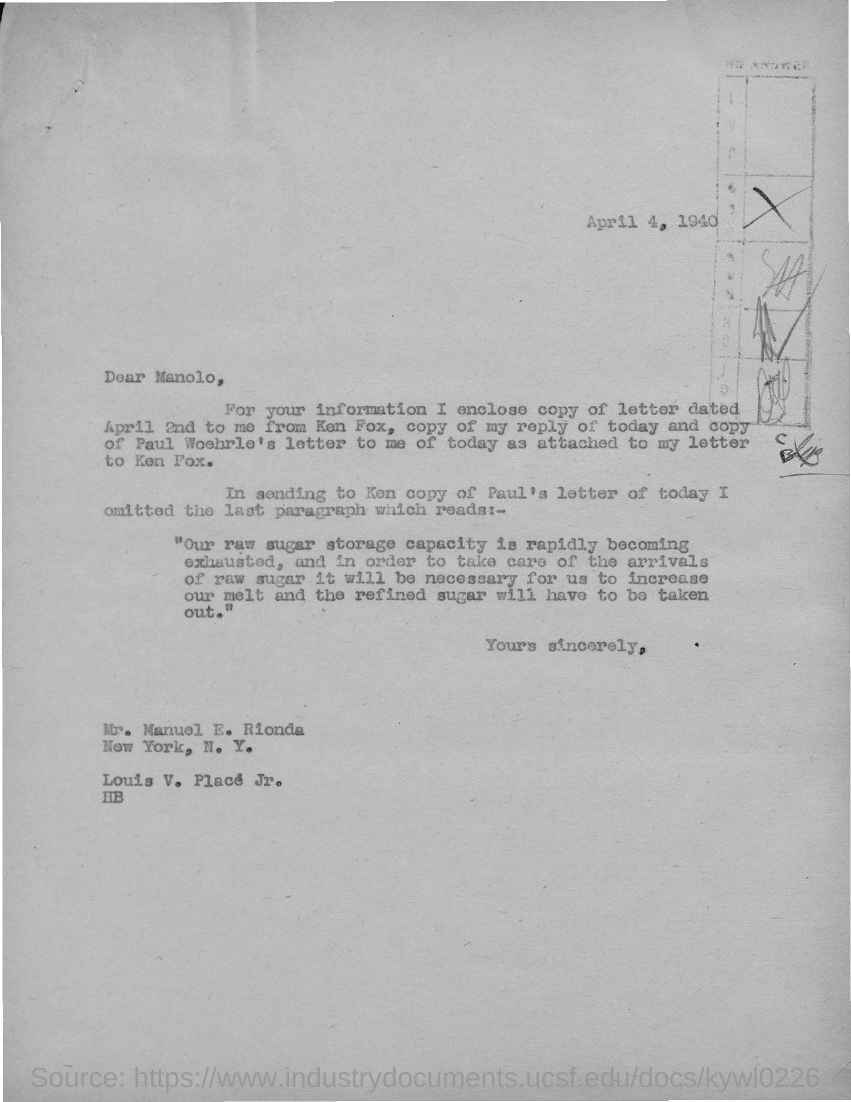Outline some significant characteristics in this image. To whom is this letter addressed to? Manolo. The letter, which is dated April 2nd, is enclosed. 